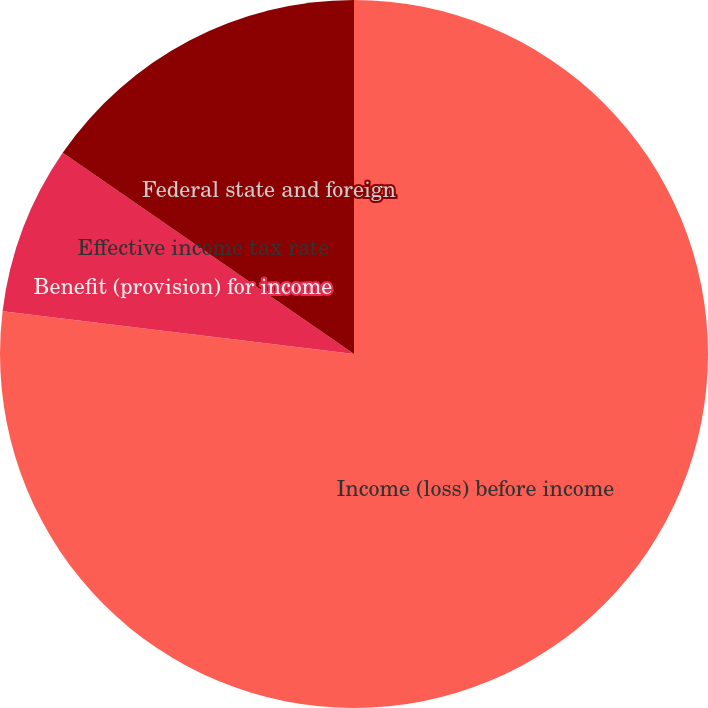Convert chart to OTSL. <chart><loc_0><loc_0><loc_500><loc_500><pie_chart><fcel>Income (loss) before income<fcel>Benefit (provision) for income<fcel>Effective income tax rate<fcel>Federal state and foreign<nl><fcel>76.92%<fcel>7.69%<fcel>0.0%<fcel>15.38%<nl></chart> 